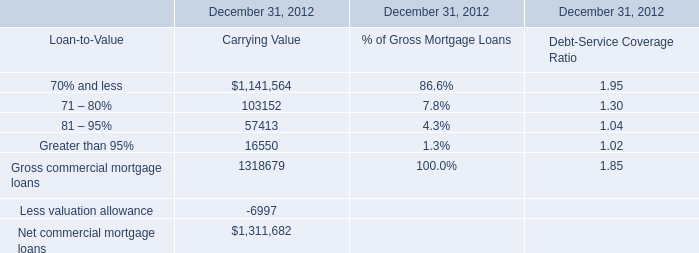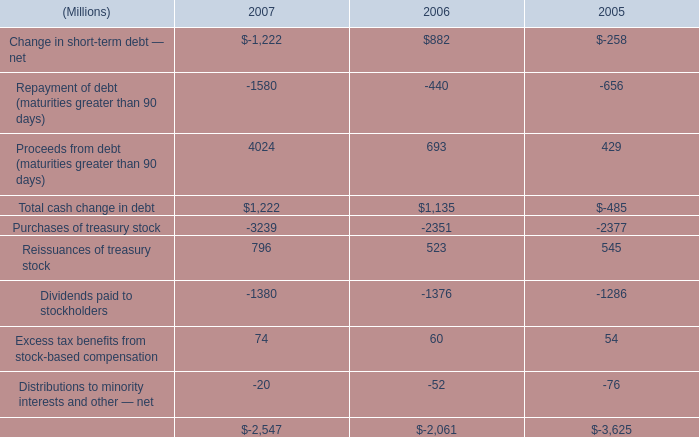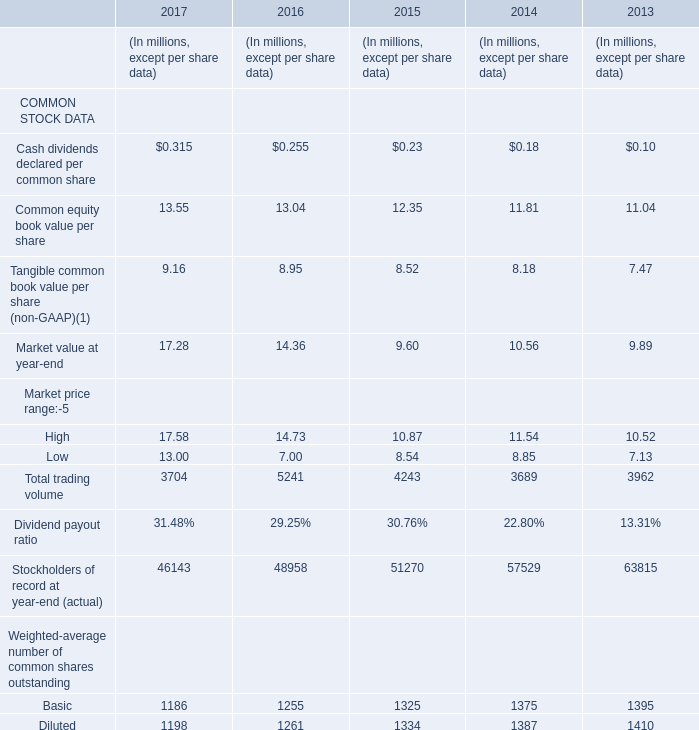What is the average amount of Net cash used in financing activities of 2007, and Net commercial mortgage loans of December 31, 2012 Carrying Value ? 
Computations: ((2547.0 + 1311682.0) / 2)
Answer: 657114.5. 